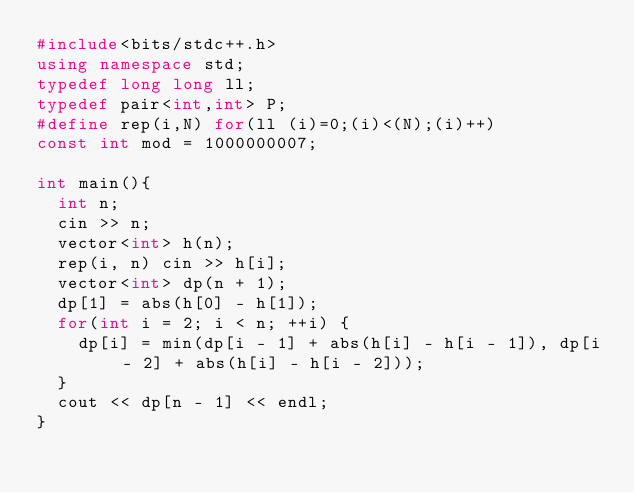Convert code to text. <code><loc_0><loc_0><loc_500><loc_500><_C++_>#include<bits/stdc++.h>
using namespace std;
typedef long long ll;
typedef pair<int,int> P;
#define rep(i,N) for(ll (i)=0;(i)<(N);(i)++)
const int mod = 1000000007;

int main(){
  int n;
  cin >> n;
  vector<int> h(n);
  rep(i, n) cin >> h[i];
  vector<int> dp(n + 1);
  dp[1] = abs(h[0] - h[1]);
  for(int i = 2; i < n; ++i) {
    dp[i] = min(dp[i - 1] + abs(h[i] - h[i - 1]), dp[i - 2] + abs(h[i] - h[i - 2]));
  }
  cout << dp[n - 1] << endl;
}</code> 